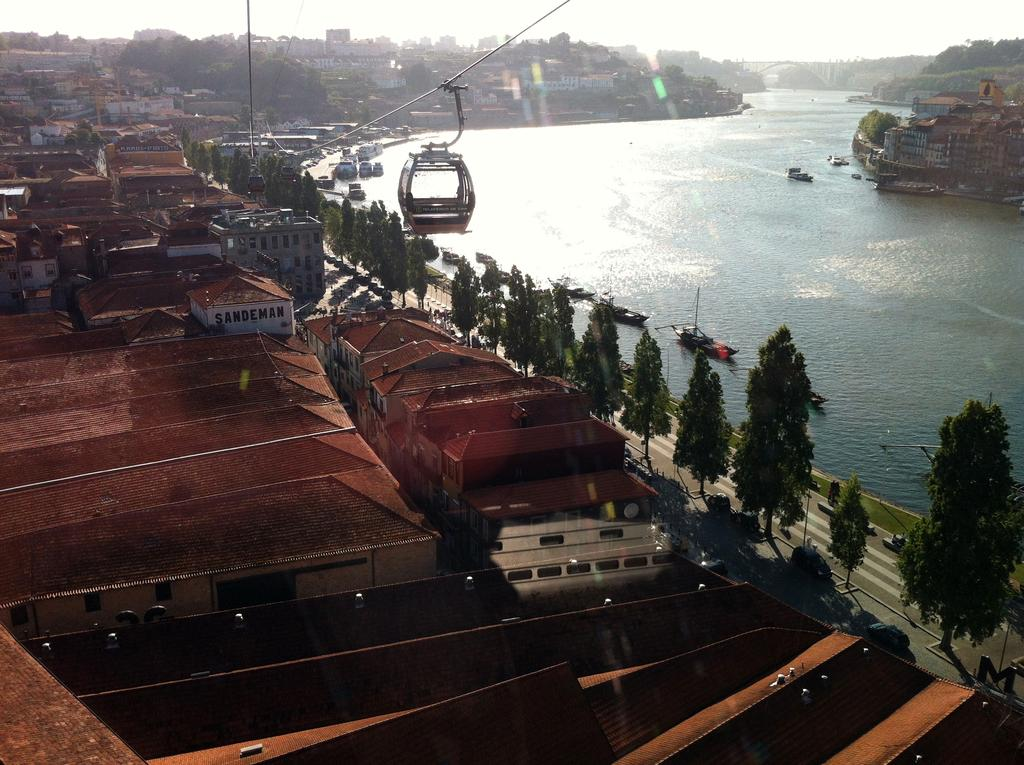What can be seen in the center of the image? The sky is visible in the center of the image. What type of natural elements are present in the image? There are trees and water in the image. What man-made structures can be seen in the image? Buildings are visible in the image. What type of vehicles are present in the image? Boats are present in the image. Are there any other objects or features in the image? Yes, there are a few other objects in the image. Can you tell me who won the argument that took place on the stream in the image? There is no argument or stream present in the image; it features the sky, trees, water, buildings, boats, and other objects. 